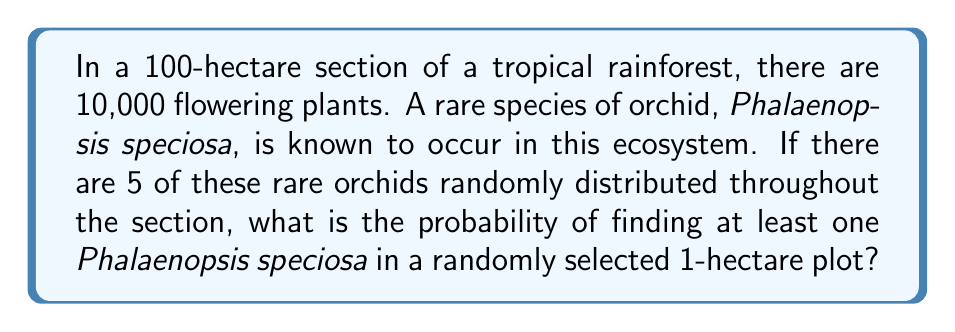Solve this math problem. Let's approach this step-by-step:

1) First, we need to calculate the probability of not finding any Phalaenopsis speciosa in a 1-hectare plot.

2) There are $\binom{100}{1} = 100$ ways to choose a 1-hectare plot from the 100-hectare section.

3) The number of ways to choose a 1-hectare plot that doesn't contain any of the 5 rare orchids is equal to the number of ways to choose 1 hectare from the 95 hectares that don't contain the orchids: $\binom{95}{1} = 95$.

4) Therefore, the probability of not finding any Phalaenopsis speciosa in a randomly selected 1-hectare plot is:

   $$P(\text{no orchids}) = \frac{\binom{95}{1}}{\binom{100}{1}} = \frac{95}{100} = 0.95$$

5) The probability of finding at least one Phalaenopsis speciosa is the complement of this probability:

   $$P(\text{at least one orchid}) = 1 - P(\text{no orchids}) = 1 - 0.95 = 0.05$$

6) Therefore, the probability of finding at least one Phalaenopsis speciosa in a randomly selected 1-hectare plot is 0.05 or 5%.
Answer: 0.05 